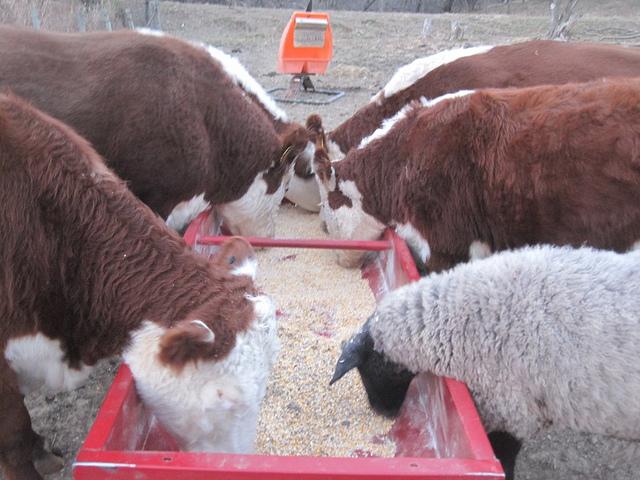How many different species in this picture?
Concise answer only. 2. What kind of food are the animals eating?
Answer briefly. Grain. What is the color of  the food rack?
Concise answer only. Red. 